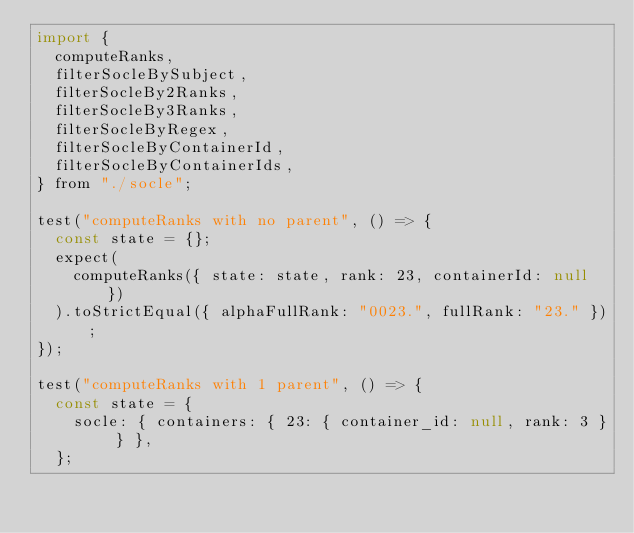<code> <loc_0><loc_0><loc_500><loc_500><_JavaScript_>import {
  computeRanks,
  filterSocleBySubject,
  filterSocleBy2Ranks,
  filterSocleBy3Ranks,
  filterSocleByRegex,
  filterSocleByContainerId,
  filterSocleByContainerIds,
} from "./socle";

test("computeRanks with no parent", () => {
  const state = {};
  expect(
    computeRanks({ state: state, rank: 23, containerId: null })
  ).toStrictEqual({ alphaFullRank: "0023.", fullRank: "23." });
});

test("computeRanks with 1 parent", () => {
  const state = {
    socle: { containers: { 23: { container_id: null, rank: 3 } } },
  };</code> 